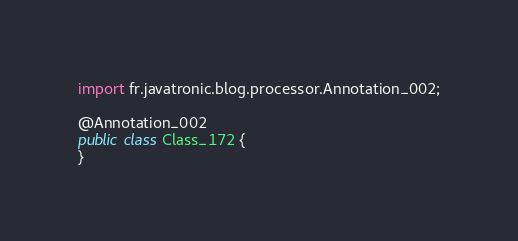Convert code to text. <code><loc_0><loc_0><loc_500><loc_500><_Java_>
import fr.javatronic.blog.processor.Annotation_002;

@Annotation_002
public class Class_172 {
}
</code> 